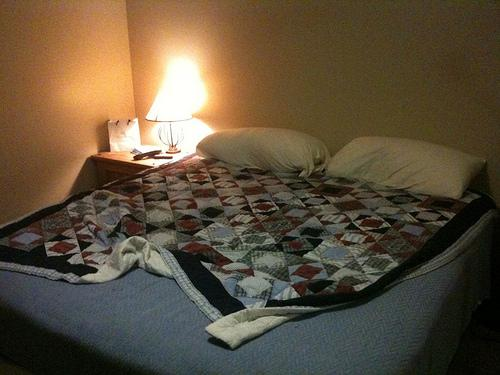Question: where are the pillows?
Choices:
A. On the couch.
B. On top of the quilt.
C. On the bed.
D. On the recliner.
Answer with the letter. Answer: B Question: why is the light on?
Choices:
A. It's nighttime.
B. The room is dark.
C. I was just there.
D. There's dark clouds out.
Answer with the letter. Answer: B Question: how many pillows are on the bed?
Choices:
A. Three.
B. One.
C. Two.
D. Five.
Answer with the letter. Answer: C Question: where is the night stand?
Choices:
A. Near bed.
B. In the room.
C. On the ground.
D. In the corner.
Answer with the letter. Answer: D Question: what room of the house is this picture taken in?
Choices:
A. Bathroom.
B. Kitchen.
C. Living Room.
D. Bedroom.
Answer with the letter. Answer: D 